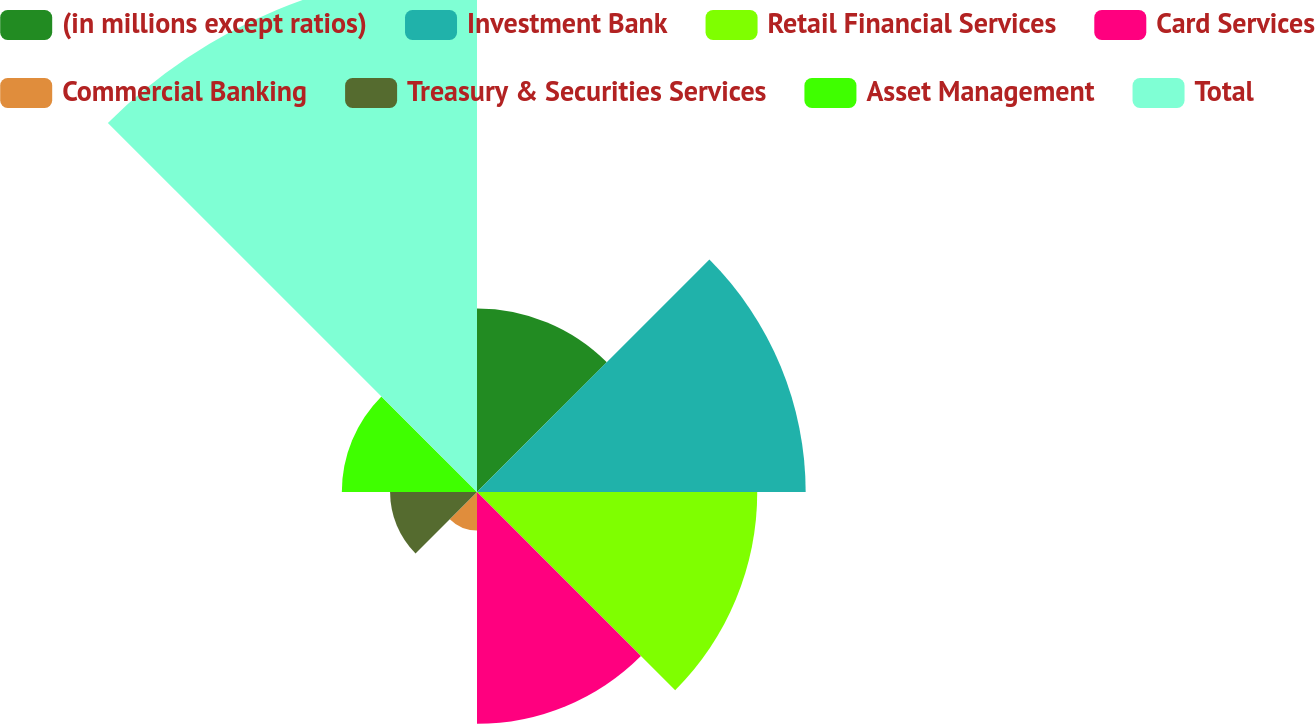Convert chart to OTSL. <chart><loc_0><loc_0><loc_500><loc_500><pie_chart><fcel>(in millions except ratios)<fcel>Investment Bank<fcel>Retail Financial Services<fcel>Card Services<fcel>Commercial Banking<fcel>Treasury & Securities Services<fcel>Asset Management<fcel>Total<nl><fcel>10.16%<fcel>18.19%<fcel>15.51%<fcel>12.83%<fcel>2.13%<fcel>4.81%<fcel>7.48%<fcel>28.89%<nl></chart> 